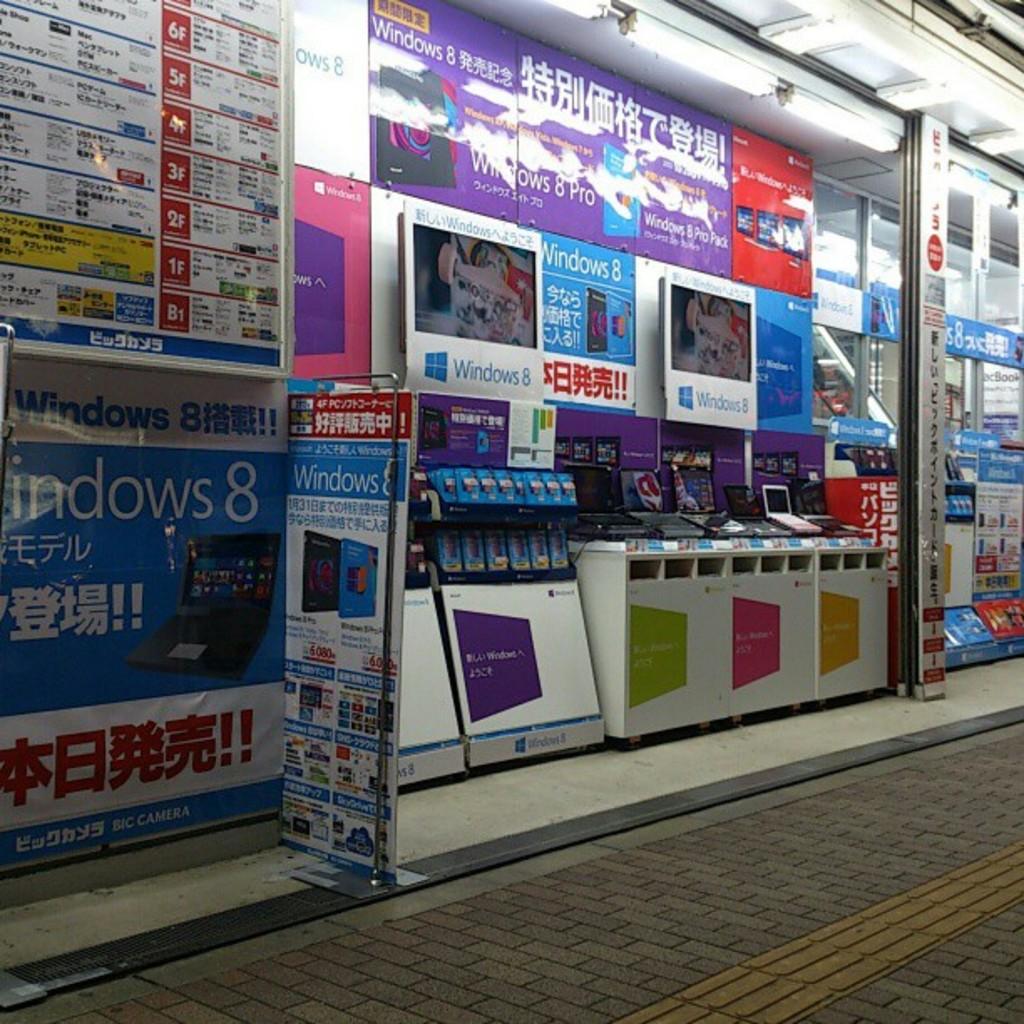What operating system does the laptop use?
Your response must be concise. Windows 8. 